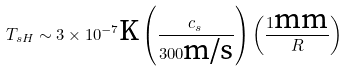Convert formula to latex. <formula><loc_0><loc_0><loc_500><loc_500>T _ { s H } \sim 3 \times 1 0 ^ { - 7 } \text {K} \left ( \frac { c _ { s } } { 3 0 0 \text {m/s} } \right ) \left ( \frac { 1 \text {mm} } { R } \right )</formula> 